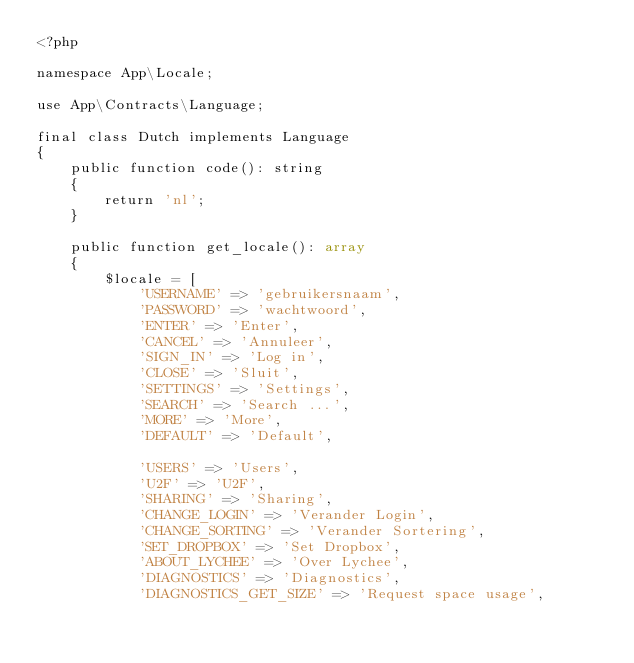Convert code to text. <code><loc_0><loc_0><loc_500><loc_500><_PHP_><?php

namespace App\Locale;

use App\Contracts\Language;

final class Dutch implements Language
{
	public function code(): string
	{
		return 'nl';
	}

	public function get_locale(): array
	{
		$locale = [
			'USERNAME' => 'gebruikersnaam',
			'PASSWORD' => 'wachtwoord',
			'ENTER' => 'Enter',
			'CANCEL' => 'Annuleer',
			'SIGN_IN' => 'Log in',
			'CLOSE' => 'Sluit',
			'SETTINGS' => 'Settings',
			'SEARCH' => 'Search ...',
			'MORE' => 'More',
			'DEFAULT' => 'Default',

			'USERS' => 'Users',
			'U2F' => 'U2F',
			'SHARING' => 'Sharing',
			'CHANGE_LOGIN' => 'Verander Login',
			'CHANGE_SORTING' => 'Verander Sortering',
			'SET_DROPBOX' => 'Set Dropbox',
			'ABOUT_LYCHEE' => 'Over Lychee',
			'DIAGNOSTICS' => 'Diagnostics',
			'DIAGNOSTICS_GET_SIZE' => 'Request space usage',</code> 